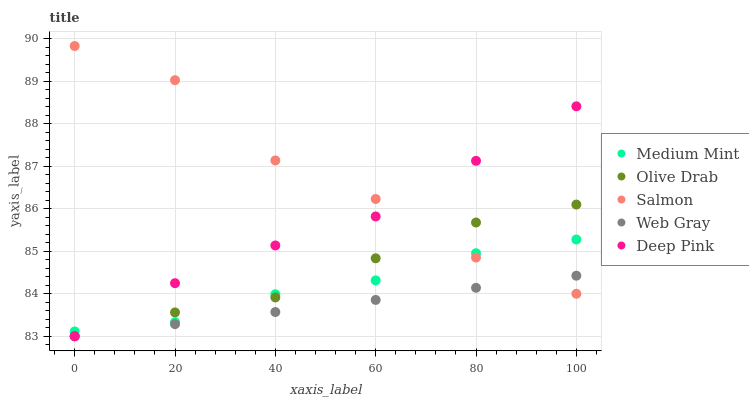Does Web Gray have the minimum area under the curve?
Answer yes or no. Yes. Does Salmon have the maximum area under the curve?
Answer yes or no. Yes. Does Salmon have the minimum area under the curve?
Answer yes or no. No. Does Web Gray have the maximum area under the curve?
Answer yes or no. No. Is Web Gray the smoothest?
Answer yes or no. Yes. Is Salmon the roughest?
Answer yes or no. Yes. Is Salmon the smoothest?
Answer yes or no. No. Is Web Gray the roughest?
Answer yes or no. No. Does Web Gray have the lowest value?
Answer yes or no. Yes. Does Salmon have the lowest value?
Answer yes or no. No. Does Salmon have the highest value?
Answer yes or no. Yes. Does Web Gray have the highest value?
Answer yes or no. No. Is Web Gray less than Medium Mint?
Answer yes or no. Yes. Is Medium Mint greater than Web Gray?
Answer yes or no. Yes. Does Salmon intersect Web Gray?
Answer yes or no. Yes. Is Salmon less than Web Gray?
Answer yes or no. No. Is Salmon greater than Web Gray?
Answer yes or no. No. Does Web Gray intersect Medium Mint?
Answer yes or no. No. 